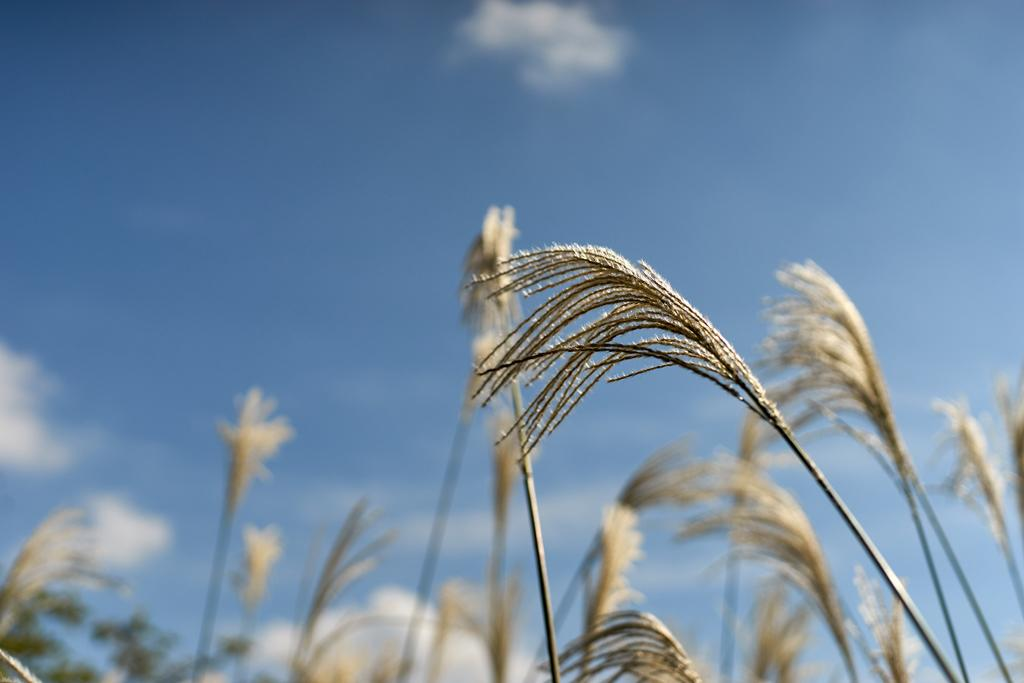What is present in the image? There are plants in the image. Can you describe the background of the image? In the background, there are plants at the bottom. What can be seen in the sky in the image? There are clouds visible in the sky. What type of bat can be seen flying near the plants in the image? There is no bat present in the image; it only features plants and clouds in the sky. 